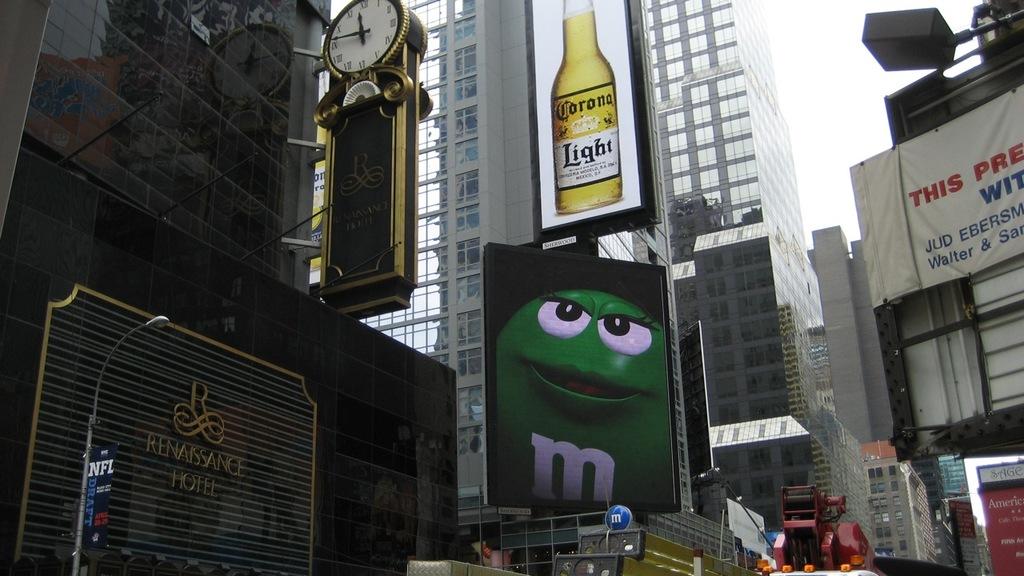What beer is being advertised?
Offer a terse response. Corona. What letter is on the green candy's chest?
Offer a very short reply. M. 